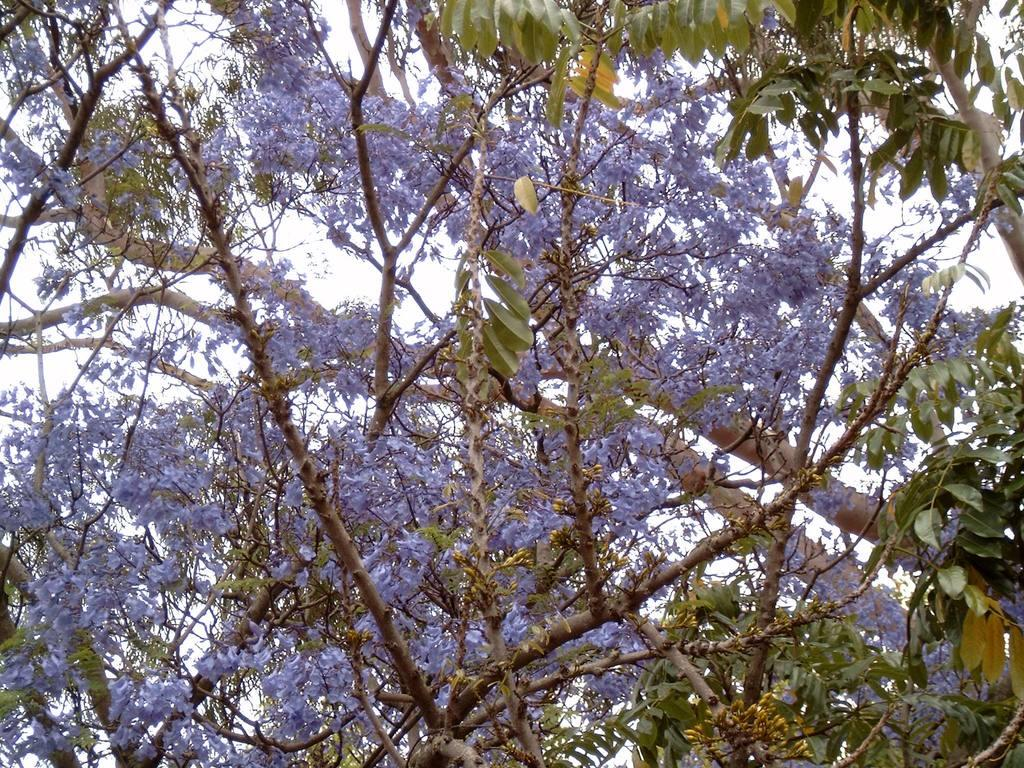What is the main subject of the image? The main subject of the image is a tree with many flowers and leaves. Can you describe the flowers and leaves in the image? The flowers and leaves are part of the tree, and there are leaves on the stems. What can be seen in the background of the image? The sky is visible in the background of the image. How many dogs are carrying a parcel in the image? There are no dogs or parcels present in the image; it features a tree with flowers and leaves. What advice might the grandmother give about the flowers in the image? There is no grandmother present in the image, so it is not possible to determine what advice she might give. 